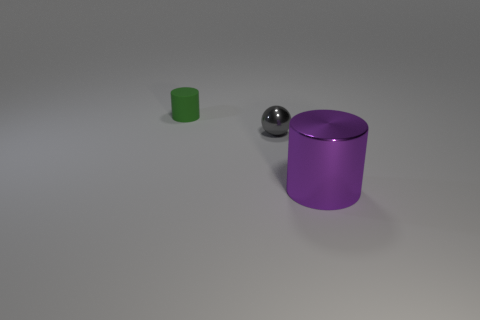Do the small rubber object and the purple object have the same shape?
Your answer should be very brief. Yes. There is a cylinder in front of the cylinder left of the purple metal thing; what is its size?
Offer a terse response. Large. There is a large shiny thing that is the same shape as the tiny green matte thing; what is its color?
Make the answer very short. Purple. How many large metallic objects are the same color as the ball?
Your answer should be very brief. 0. How big is the gray metal ball?
Your answer should be compact. Small. Do the rubber object and the gray shiny object have the same size?
Offer a very short reply. Yes. The object that is both to the right of the tiny cylinder and on the left side of the large purple object is what color?
Your answer should be compact. Gray. How many small gray things are the same material as the tiny green cylinder?
Offer a very short reply. 0. How many green shiny balls are there?
Provide a short and direct response. 0. Is the size of the purple metal cylinder the same as the thing that is on the left side of the gray object?
Ensure brevity in your answer.  No. 